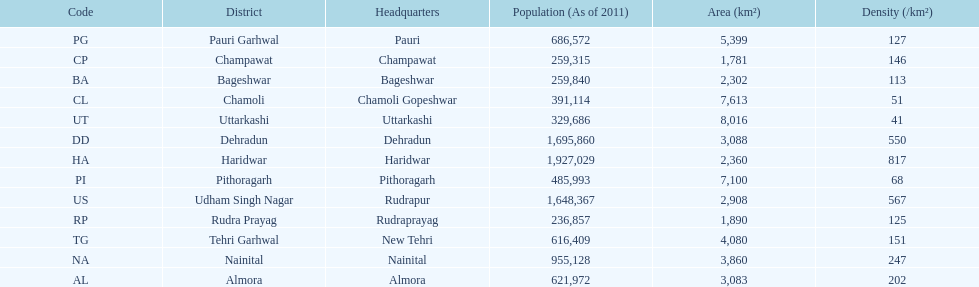Which headquarter has the same district name but has a density of 202? Almora. 